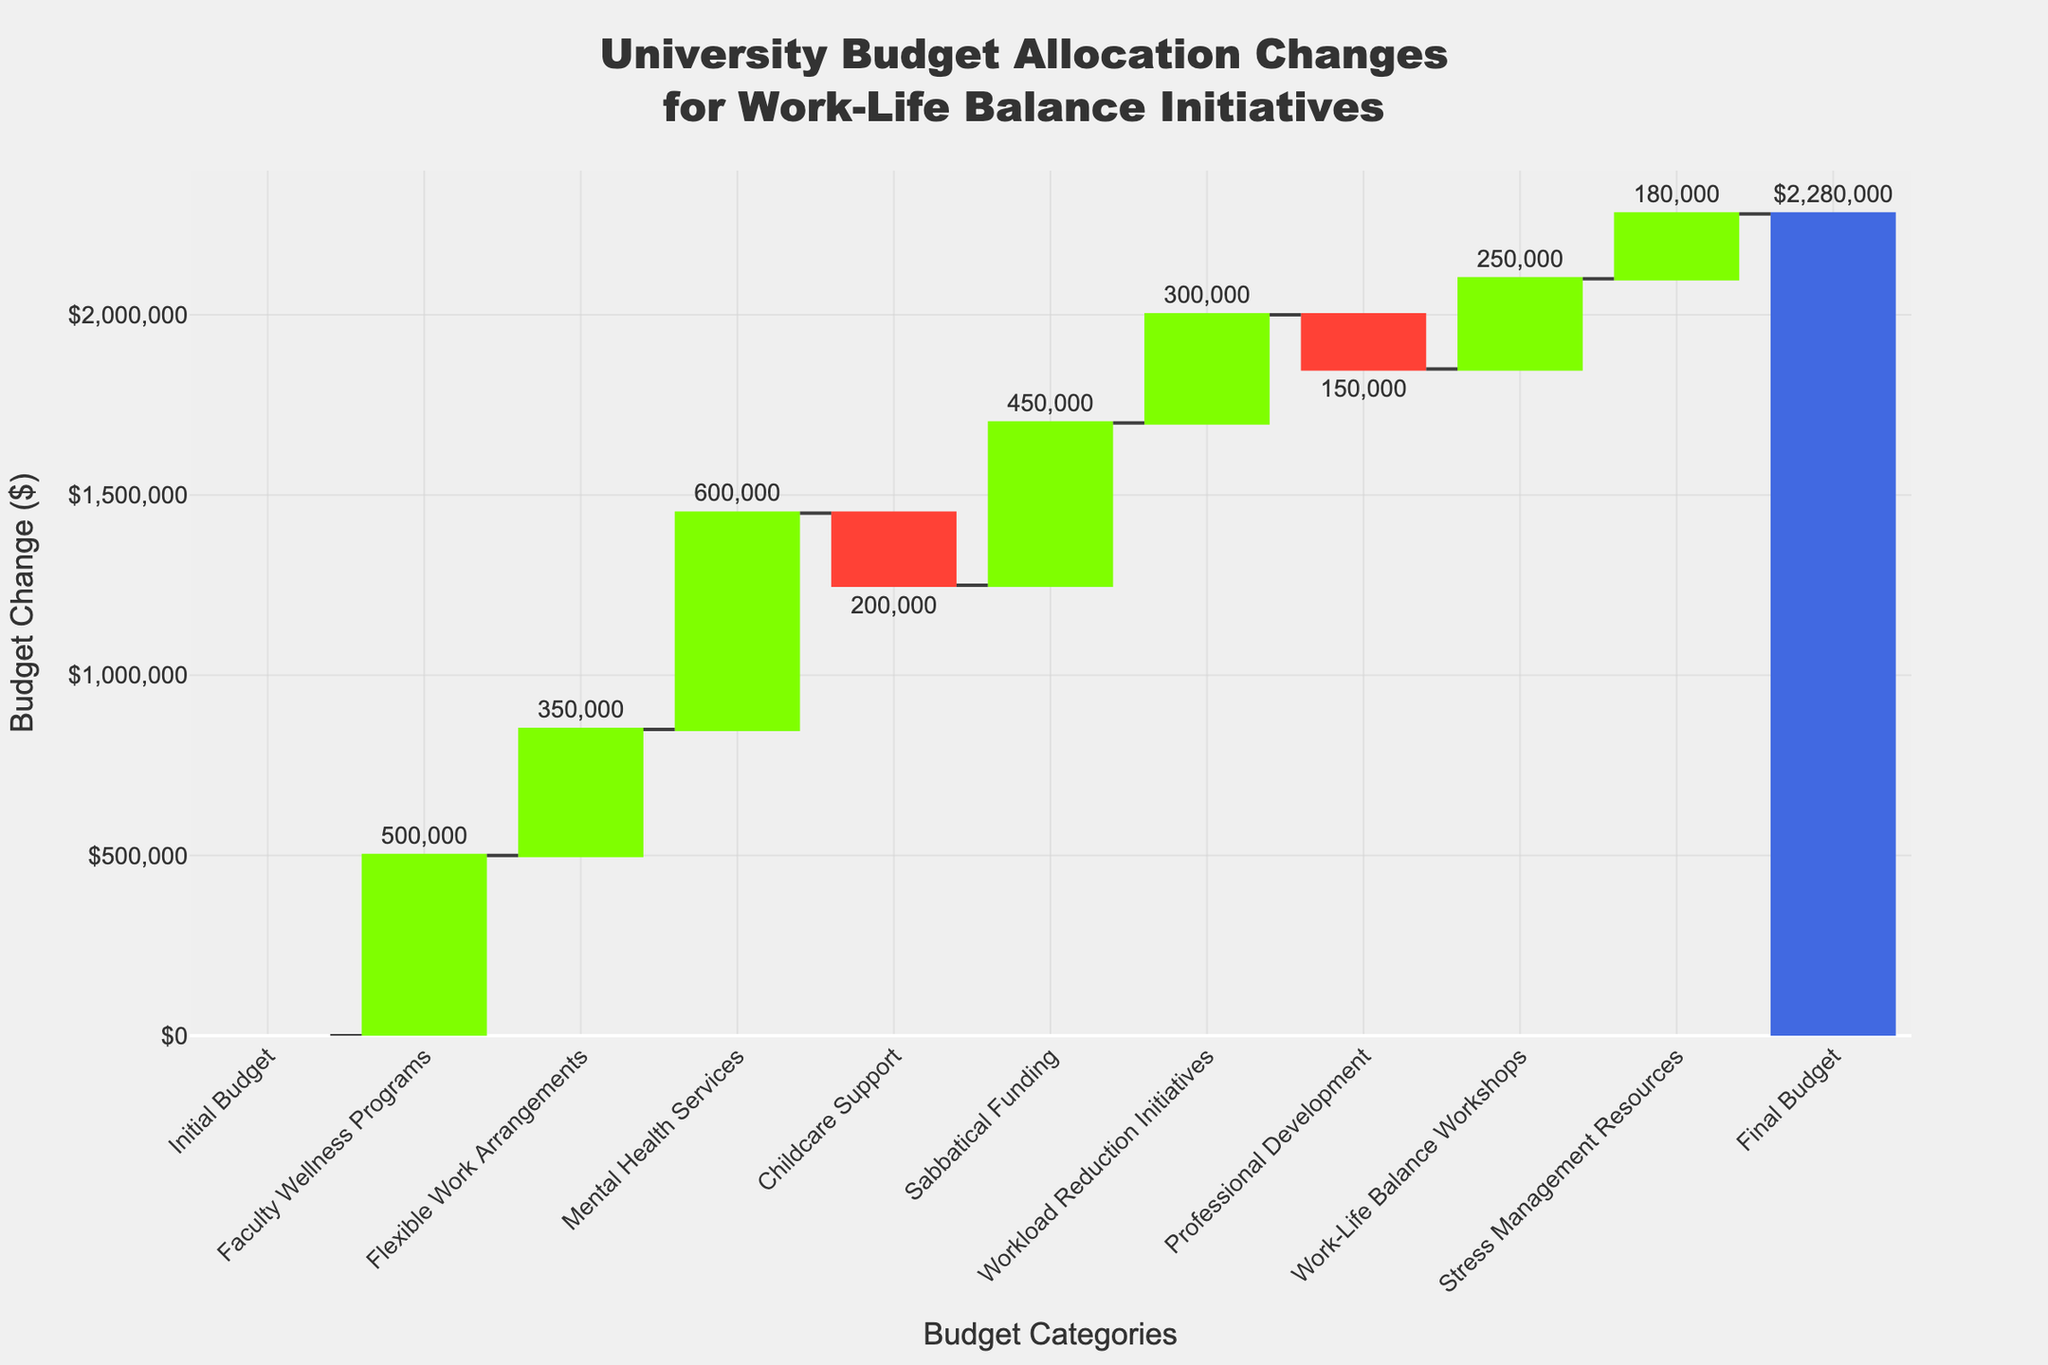Which category saw the largest budget increase? By examining the plot, look at the height of the bars that represent an increase in budget. The category with the tallest green bar is "Mental Health Services" which saw an increase of $600,000.
Answer: Mental Health Services What is the final budget after all changes? The final point in a waterfall chart represents the total after all the changes have been applied. According to the values from the plot, the final budget figure is $2,280,000.
Answer: $2,280,000 How much budget was allocated to Flexible Work Arrangements? Look at the bar labeled "Flexible Work Arrangements," which shows a budget increase. The value at the top of this bar indicates an increase of $350,000.
Answer: $350,000 Which categories saw a budget decrease? Identify the red bars, which denote budget decreases. There are two red bars corresponding to "Childcare Support" and "Professional Development."
Answer: Childcare Support, Professional Development What was the net change in budget for Childcare Support and Sabbatical Funding combined? Childcare Support saw a decrease of $200,000, and Sabbatical Funding saw an increase of $450,000. The net change is calculated as $450,000 - $200,000, resulting in a net increase of $250,000.
Answer: $250,000 Did Workload Reduction Initiatives receive more budget than Work-Life Balance Workshops? Compare the bars for "Workload Reduction Initiatives" and "Work-Life Balance Workshops." Workload Reduction Initiatives saw an increase of $300,000, whereas Work-Life Balance Workshops saw an increase of $250,000. Thus, Workload Reduction Initiatives received more budget.
Answer: Yes What percentage of the total budget changes was allocated to Mental Health Services? The increase for Mental Health Services is $600,000. The total budget increase excluding the final total is the sum of all the positive and negative changes (500000 + 350000 + 600000 - 200000 + 450000 + 300000 - 150000 + 250000 + 180000 = $2,280,000). The percentage is calculated as (600000 / 2280000) * 100%, which is approximately 26.32%.
Answer: 26.32% How many categories resulted in a positive, negative, or no change in budget? Count the number of green, red, and zero-height bars. There are 7 positive changes (green bars), 2 negative changes (red bars), and 0 neutral changes (zero-height bars).
Answer: 7 positive, 2 negative, 0 neutral What is the total budget change from Professional Development and Stress Management Resources combined? Professional Development has a budget decrease of $150,000, and Stress Management Resources has a budget increase of $180,000. The total change is $180,000 - $150,000 = $30,000.
Answer: $30,000 Which category saw the smallest budget increase? Among the green bars representing increases, the one corresponding to "Work-Life Balance Workshops" shows the smallest increase of $250,000.
Answer: Work-Life Balance Workshops 